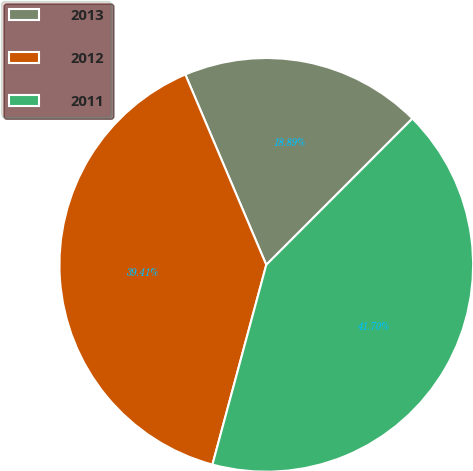Convert chart. <chart><loc_0><loc_0><loc_500><loc_500><pie_chart><fcel>2013<fcel>2012<fcel>2011<nl><fcel>18.89%<fcel>39.41%<fcel>41.7%<nl></chart> 